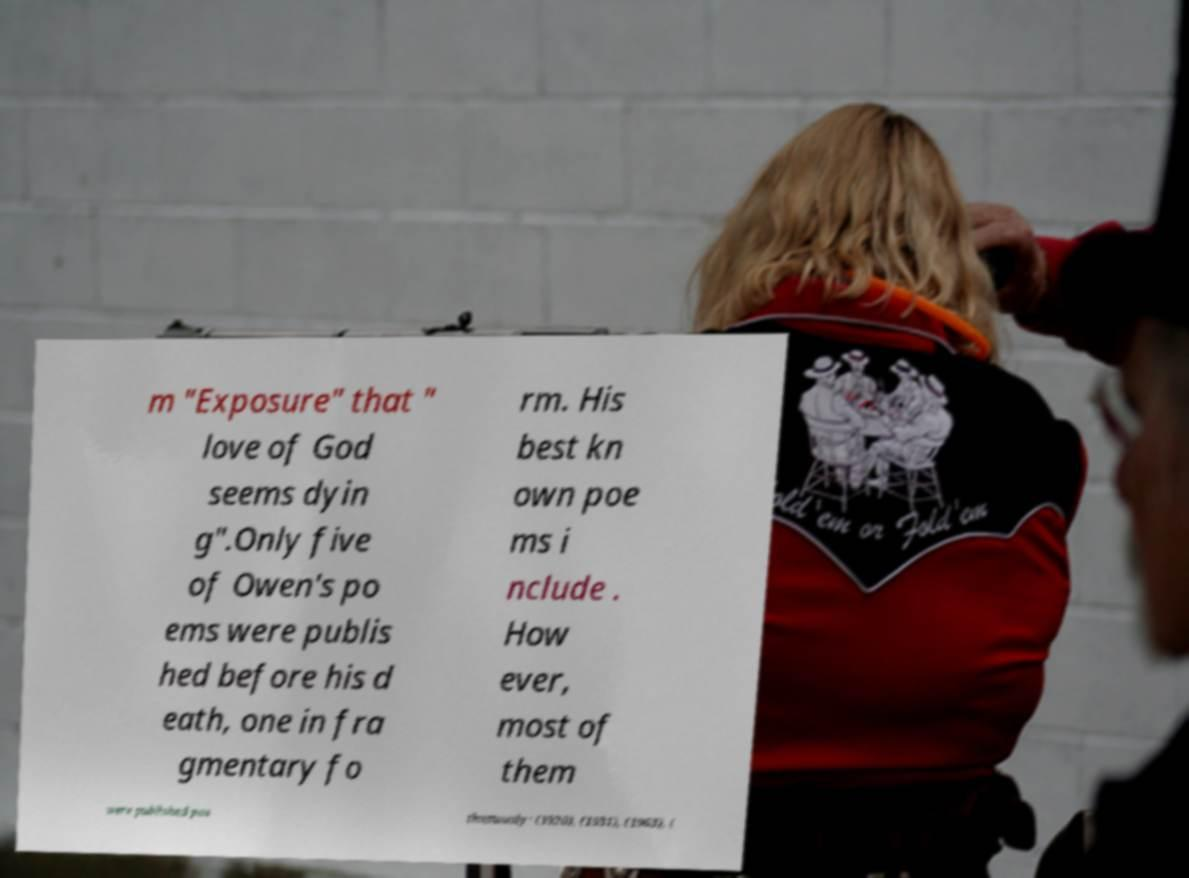Please read and relay the text visible in this image. What does it say? m "Exposure" that " love of God seems dyin g".Only five of Owen's po ems were publis hed before his d eath, one in fra gmentary fo rm. His best kn own poe ms i nclude . How ever, most of them were published pos thumously: (1920), (1931), (1963), ( 